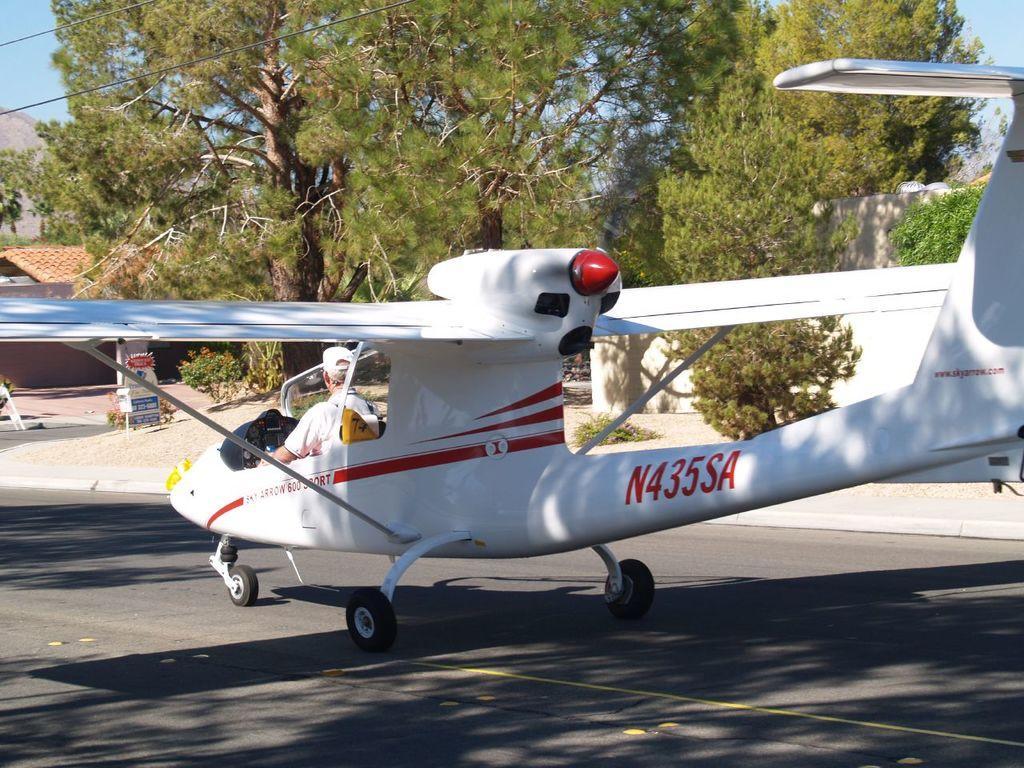Please provide a concise description of this image. In this picture I can observe an airplane on the runway. In the background there are trees and sky. 